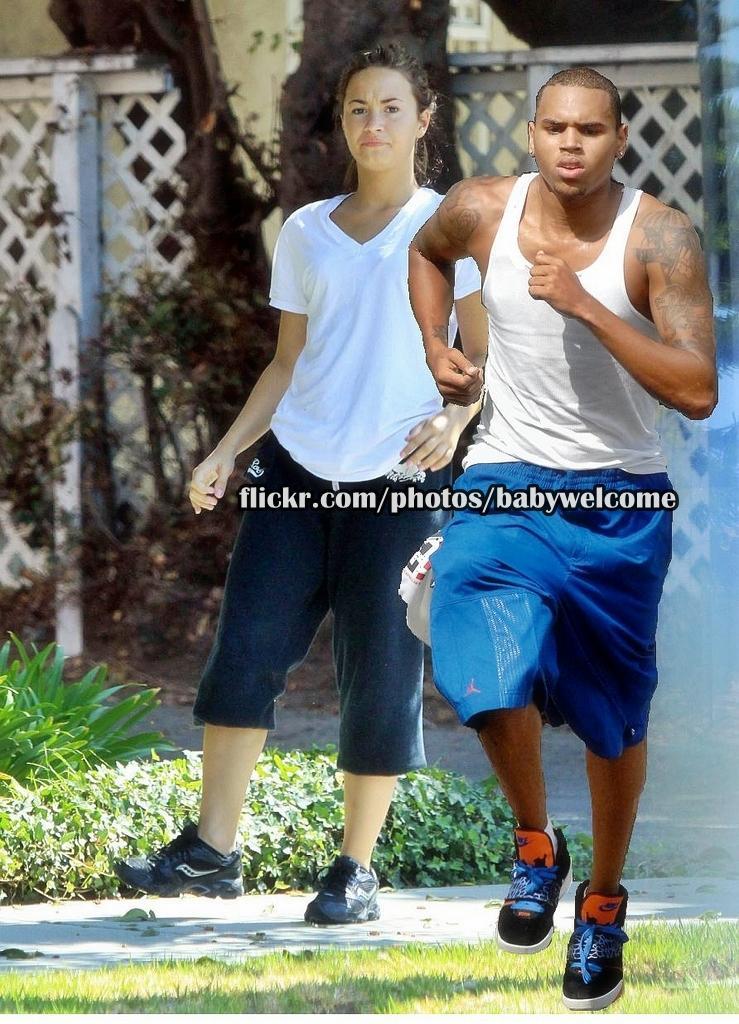In one or two sentences, can you explain what this image depicts? On the right there is a man running and behind him there is a woman walking on the ground. In the background there are trees,fence,wall and plants. 